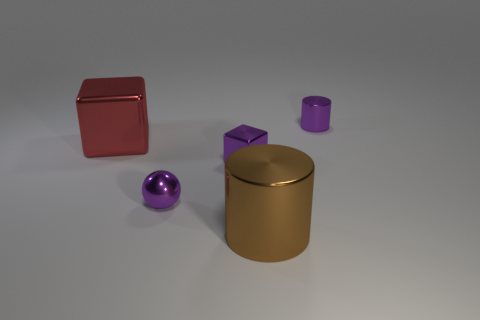There is a thing that is behind the tiny cube and to the right of the red object; what is its size?
Your answer should be very brief. Small. What is the material of the cylinder that is the same color as the tiny ball?
Provide a succinct answer. Metal. What is the size of the other metallic thing that is the same shape as the large red metallic object?
Give a very brief answer. Small. Is the color of the small thing in front of the tiny cube the same as the small block?
Ensure brevity in your answer.  Yes. What number of other objects are there of the same color as the tiny shiny cylinder?
Make the answer very short. 2. There is a metal cylinder that is behind the block that is on the left side of the tiny purple shiny ball; what size is it?
Offer a very short reply. Small. Is there a purple sphere that has the same material as the big red thing?
Make the answer very short. Yes. There is a object that is behind the big thing behind the cylinder that is in front of the large red object; what is its shape?
Provide a succinct answer. Cylinder. Does the metal cylinder that is behind the red metal cube have the same color as the cube that is right of the small sphere?
Offer a very short reply. Yes. There is a big brown thing; are there any balls on the left side of it?
Provide a short and direct response. Yes. 